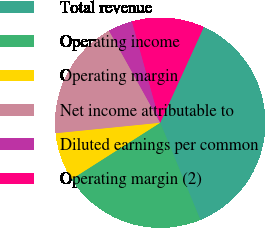Convert chart. <chart><loc_0><loc_0><loc_500><loc_500><pie_chart><fcel>Total revenue<fcel>Operating income<fcel>Operating margin<fcel>Net income attributable to<fcel>Diluted earnings per common<fcel>Operating margin (2)<nl><fcel>36.96%<fcel>22.2%<fcel>7.44%<fcel>18.51%<fcel>3.75%<fcel>11.13%<nl></chart> 